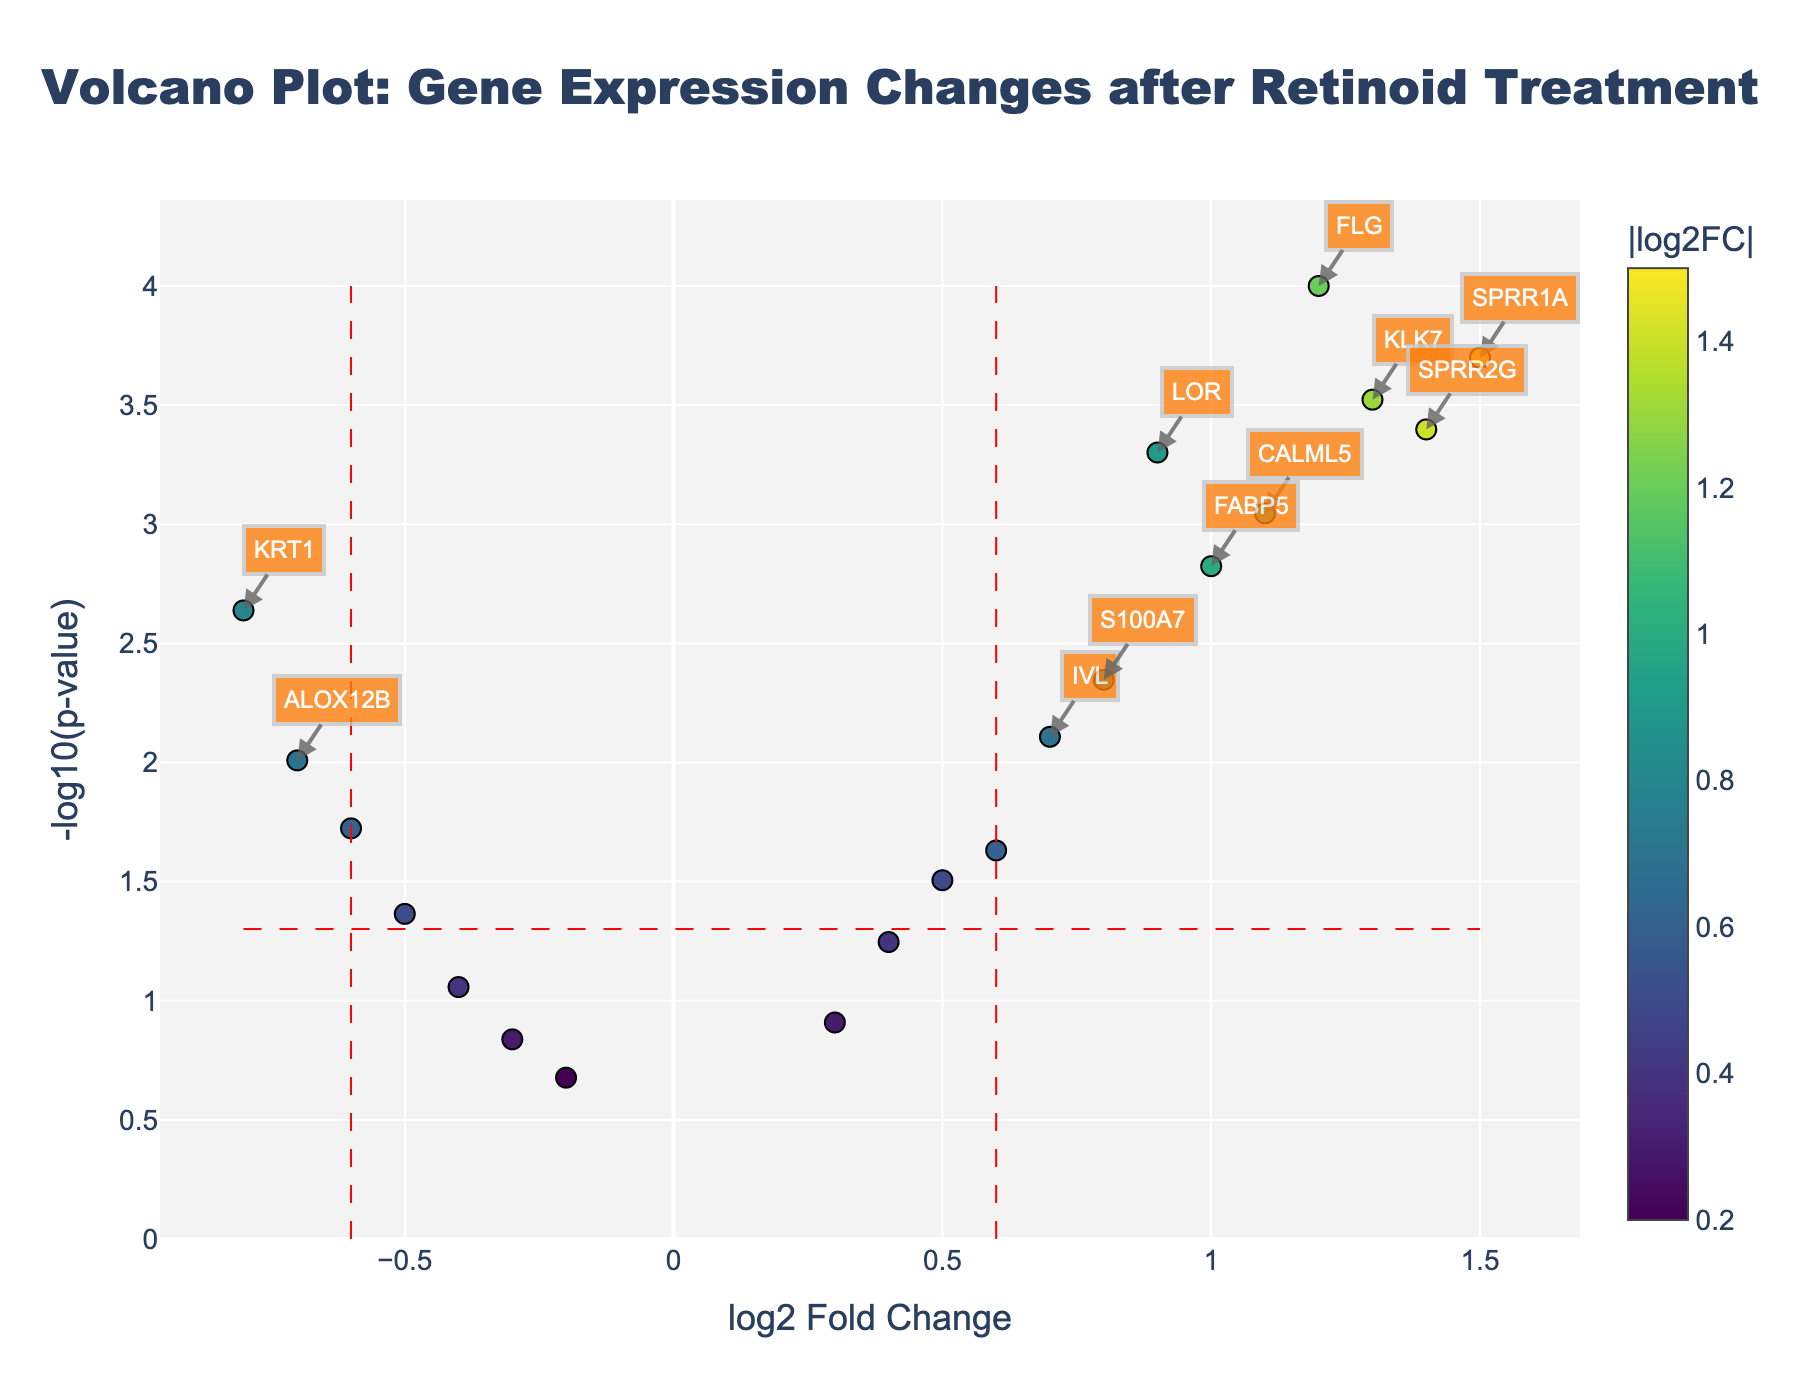What is the title of the plot? The title of the plot is located at the top and reads, "Volcano Plot: Gene Expression Changes after Retinoid Treatment".
Answer: Volcano Plot: Gene Expression Changes after Retinoid Treatment Which axis represents the log2 fold change? The x-axis is labeled as "log2 Fold Change" and represents the log2 fold change of gene expression.
Answer: x-axis What does the y-axis represent? The y-axis is labeled as "-log10(p-value)" and represents the negative logarithm (base 10) of the p-value of gene expression changes.
Answer: -log10(p-value) How many genes have a log2 fold change greater than 0.6 and a p-value less than 0.05? By examining the plot, we look for points to the right of the vertical line at log2 fold change 0.6 and above the horizontal line at -log10(p-value) 1.3 (which corresponds to a p-value of 0.05). There are 8 such genes: FLG, LOR, IVL, SPRR1A, CALML5, S100A7, KLK7, and SPRR2G.
Answer: 8 Which gene has the highest log2 fold change? The gene with the point furthest to the right on the x-axis has the highest log2 fold change. This gene is SPRR1A.
Answer: SPRR1A What is the p-value threshold used to determine significance? The figure has a horizontal dashed red line, which indicates the p-value threshold for significance. The y-axis value where this line is located is 1.3, which corresponds to a p-value of 0.05 (-log10(0.05) = 1.3).
Answer: 0.05 Are there more upregulated or downregulated genes with significant changes? To answer this, count the number of significant genes (p-value < 0.05) that are to the right of the origin (upregulated with positive log2 FC) and compare it to those to the left (downregulated with negative log2 FC). There are 8 upregulated and 4 downregulated significant genes.
Answer: More upregulated Which gene is closest to having no change in expression? The gene closest to the y-axis value of log2 fold change = 0 is the one with the smallest absolute value of log2 fold change. This gene is SPINK5 with a log2 fold change of -0.2.
Answer: SPINK5 List two genes with log2 fold change less than -0.6. By identifying points to the left of the vertical dashed red line at log2 fold change -0.6, the genes are KRT1 and ALOX12B.
Answer: KRT1, ALOX12B 